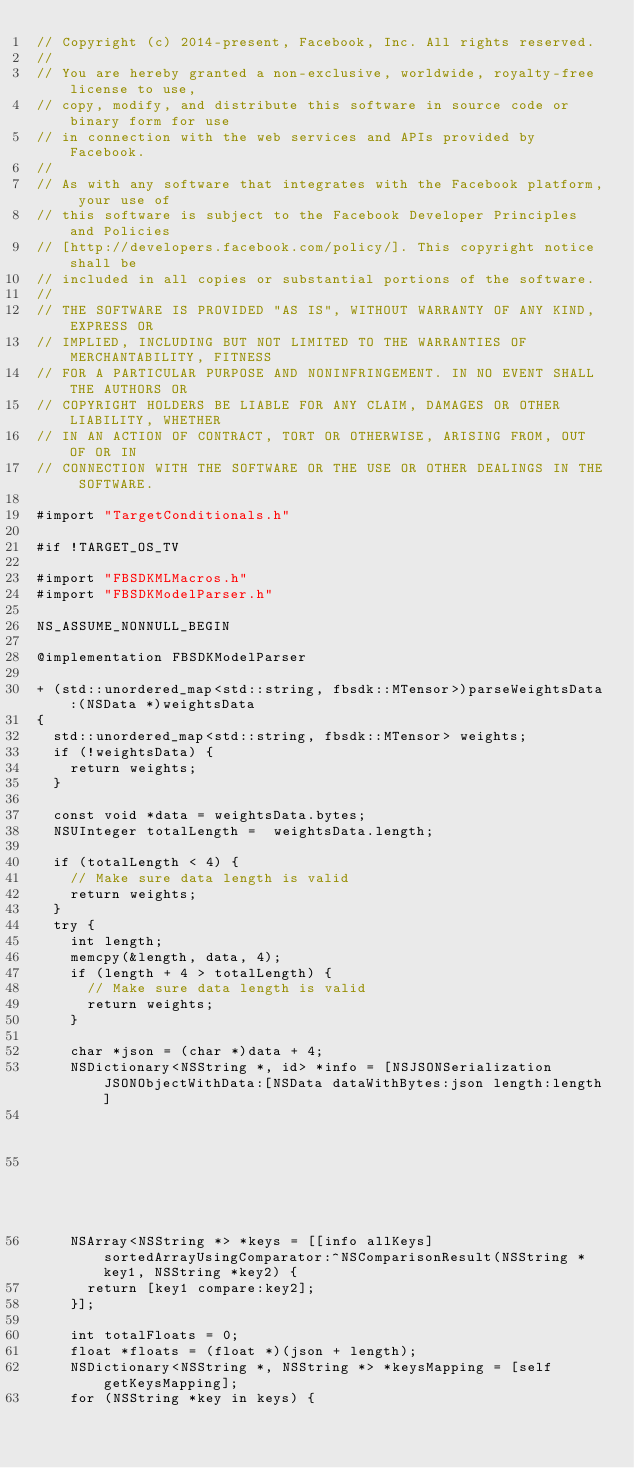<code> <loc_0><loc_0><loc_500><loc_500><_ObjectiveC_>// Copyright (c) 2014-present, Facebook, Inc. All rights reserved.
//
// You are hereby granted a non-exclusive, worldwide, royalty-free license to use,
// copy, modify, and distribute this software in source code or binary form for use
// in connection with the web services and APIs provided by Facebook.
//
// As with any software that integrates with the Facebook platform, your use of
// this software is subject to the Facebook Developer Principles and Policies
// [http://developers.facebook.com/policy/]. This copyright notice shall be
// included in all copies or substantial portions of the software.
//
// THE SOFTWARE IS PROVIDED "AS IS", WITHOUT WARRANTY OF ANY KIND, EXPRESS OR
// IMPLIED, INCLUDING BUT NOT LIMITED TO THE WARRANTIES OF MERCHANTABILITY, FITNESS
// FOR A PARTICULAR PURPOSE AND NONINFRINGEMENT. IN NO EVENT SHALL THE AUTHORS OR
// COPYRIGHT HOLDERS BE LIABLE FOR ANY CLAIM, DAMAGES OR OTHER LIABILITY, WHETHER
// IN AN ACTION OF CONTRACT, TORT OR OTHERWISE, ARISING FROM, OUT OF OR IN
// CONNECTION WITH THE SOFTWARE OR THE USE OR OTHER DEALINGS IN THE SOFTWARE.

#import "TargetConditionals.h"

#if !TARGET_OS_TV

#import "FBSDKMLMacros.h"
#import "FBSDKModelParser.h"

NS_ASSUME_NONNULL_BEGIN

@implementation FBSDKModelParser

+ (std::unordered_map<std::string, fbsdk::MTensor>)parseWeightsData:(NSData *)weightsData
{
  std::unordered_map<std::string, fbsdk::MTensor> weights;
  if (!weightsData) {
    return weights;
  }

  const void *data = weightsData.bytes;
  NSUInteger totalLength =  weightsData.length;

  if (totalLength < 4) {
    // Make sure data length is valid
    return weights;
  }
  try {
    int length;
    memcpy(&length, data, 4);
    if (length + 4 > totalLength) {
      // Make sure data length is valid
      return weights;
    }

    char *json = (char *)data + 4;
    NSDictionary<NSString *, id> *info = [NSJSONSerialization JSONObjectWithData:[NSData dataWithBytes:json length:length]
                                                                         options:0
                                                                           error:nil];
    NSArray<NSString *> *keys = [[info allKeys] sortedArrayUsingComparator:^NSComparisonResult(NSString *key1, NSString *key2) {
      return [key1 compare:key2];
    }];

    int totalFloats = 0;
    float *floats = (float *)(json + length);
    NSDictionary<NSString *, NSString *> *keysMapping = [self getKeysMapping];
    for (NSString *key in keys) {</code> 